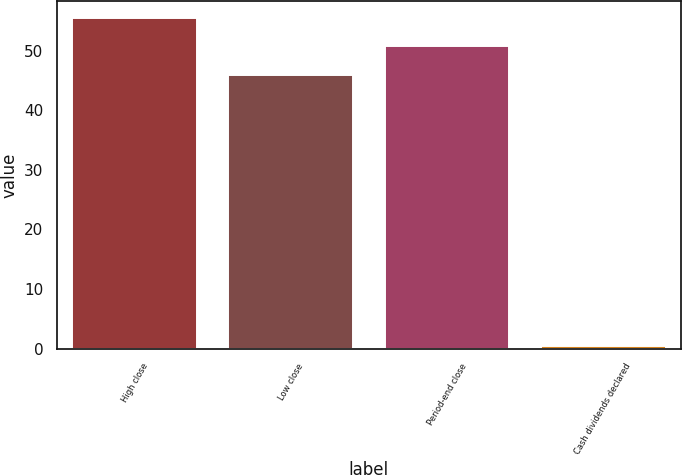Convert chart to OTSL. <chart><loc_0><loc_0><loc_500><loc_500><bar_chart><fcel>High close<fcel>Low close<fcel>Period-end close<fcel>Cash dividends declared<nl><fcel>55.55<fcel>45.93<fcel>50.74<fcel>0.34<nl></chart> 